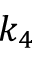<formula> <loc_0><loc_0><loc_500><loc_500>k _ { 4 }</formula> 